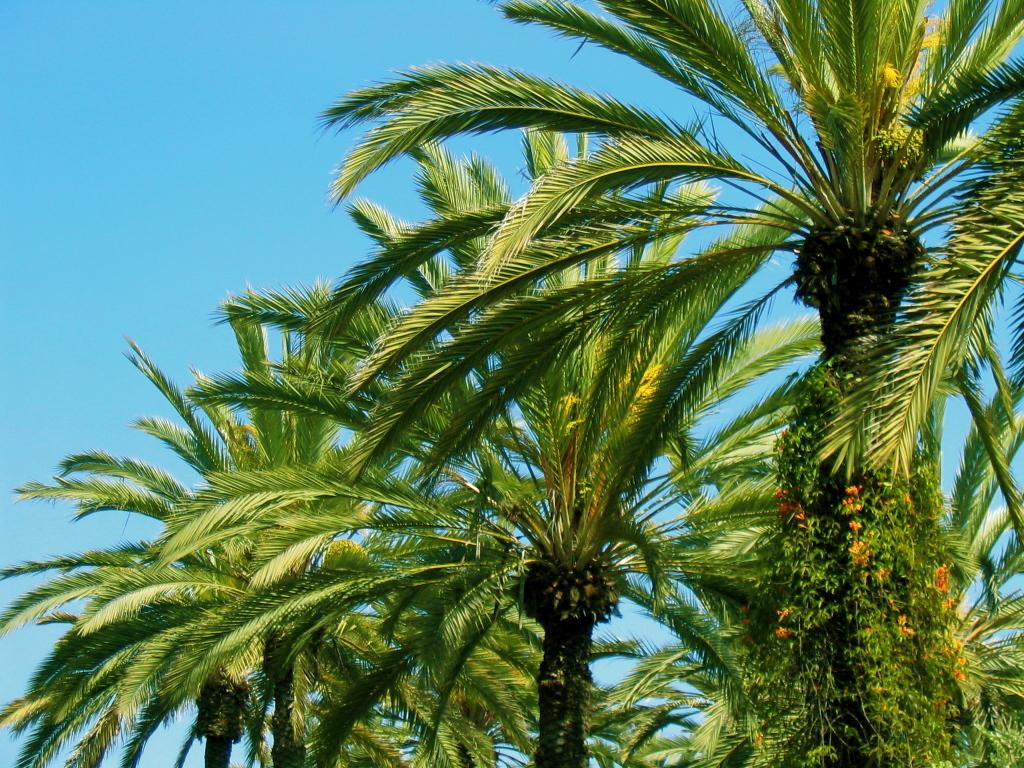What is the main subject in the center of the image? There are trees in the center of the image. What type of vegetation can be seen on the right side of the image? There are climbing plants and flowers on the right side of the image. What can be seen in the background of the image? The sky is visible in the background of the image. Are there any fairies flying around the trees in the image? There is no indication of fairies in the image; it only features trees, climbing plants, flowers, and the sky. 